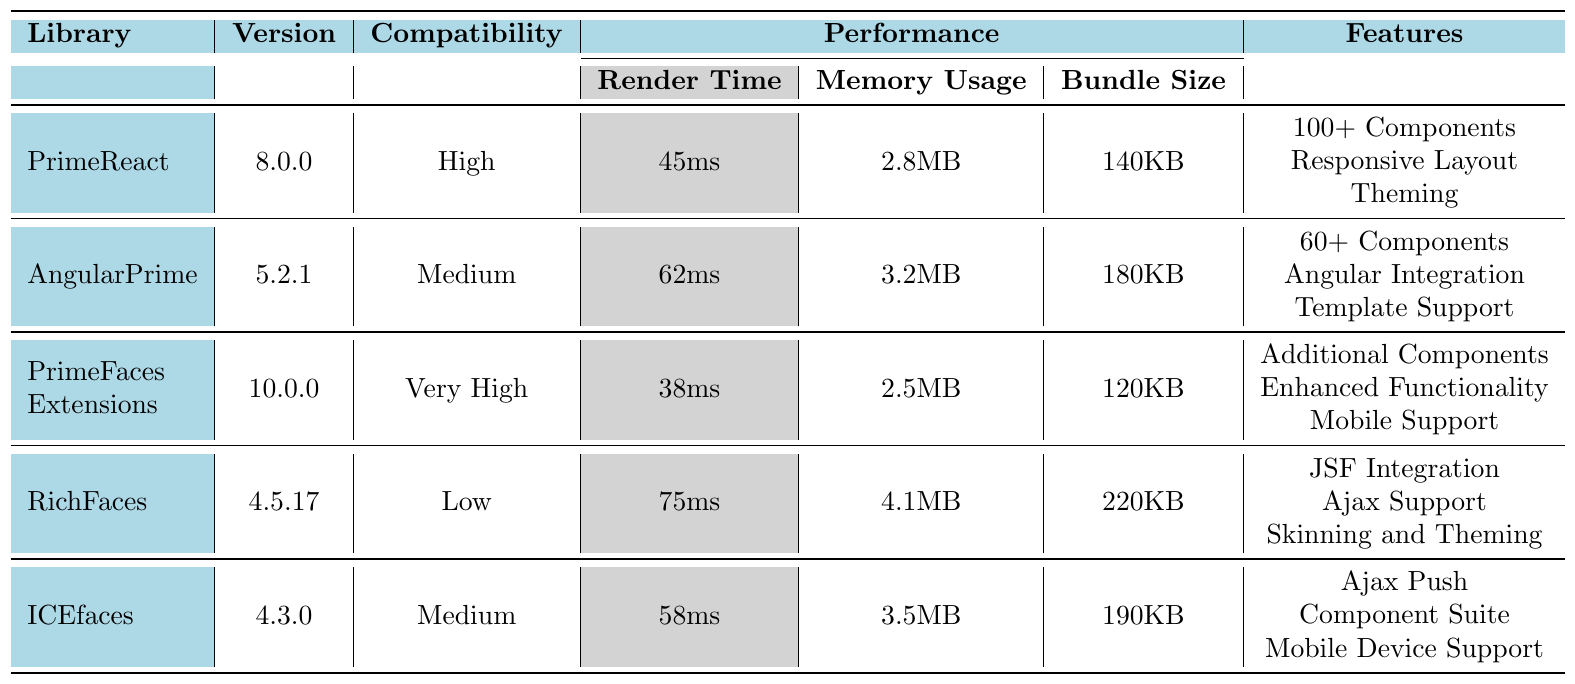What is the render time of PrimeFaces Extensions? The table shows that the render time of PrimeFaces Extensions is 38ms.
Answer: 38ms Which library has the highest memory usage? By comparing the memory usage values, RichFaces has the highest memory usage at 4.1MB.
Answer: RichFaces Is ICEfaces compatible with PrimeFaces? The compatibility rating for ICEfaces in the table is Medium, which indicates it is compatible but not at a high level.
Answer: Yes What is the average render time of all listed libraries? Calculating the render times: (45 + 62 + 38 + 75 + 58) = 278ms. Then dividing by the number of libraries (5), we get 278/5 = 55.6ms.
Answer: 55.6ms Which library has the lowest bundle size? The table indicates that PrimeFaces Extensions has the lowest bundle size at 120KB.
Answer: PrimeFaces Extensions Does AngularPrime support more components than ICEfaces? AngularPrime supports 60+ components, while ICEfaces supports an unspecified number but is not stated to exceed that, thus yes, AngularPrime supports more.
Answer: Yes What are the features provided by PrimeReact? The features of PrimeReact listed in the table are 100+ Components, Responsive Layout, and Theming.
Answer: 100+ Components, Responsive Layout, Theming If the render time of RichFaces were to decrease by 10ms, what would its new render time be? RichFaces currently has a render time of 75ms. After decreasing by 10ms, its new render time would be 75 - 10 = 65ms.
Answer: 65ms Which library has the same compatibility rating as ICEfaces? The compatibility rating for ICEfaces is Medium. The library with the same rating is AngularPrime.
Answer: AngularPrime How much lower is the memory usage of PrimeFaces Extensions compared to RichFaces? PrimeFaces Extensions has a memory usage of 2.5MB, while RichFaces has 4.1MB. The difference is 4.1 - 2.5 = 1.6MB.
Answer: 1.6MB Which library has enhanced functionality as a feature? According to the table, PrimeFaces Extensions is the library that offers enhanced functionality.
Answer: PrimeFaces Extensions 